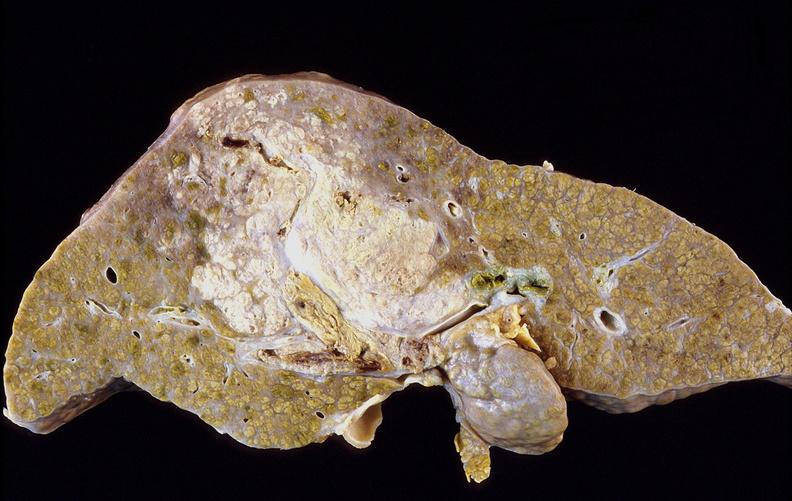s simian crease present?
Answer the question using a single word or phrase. No 